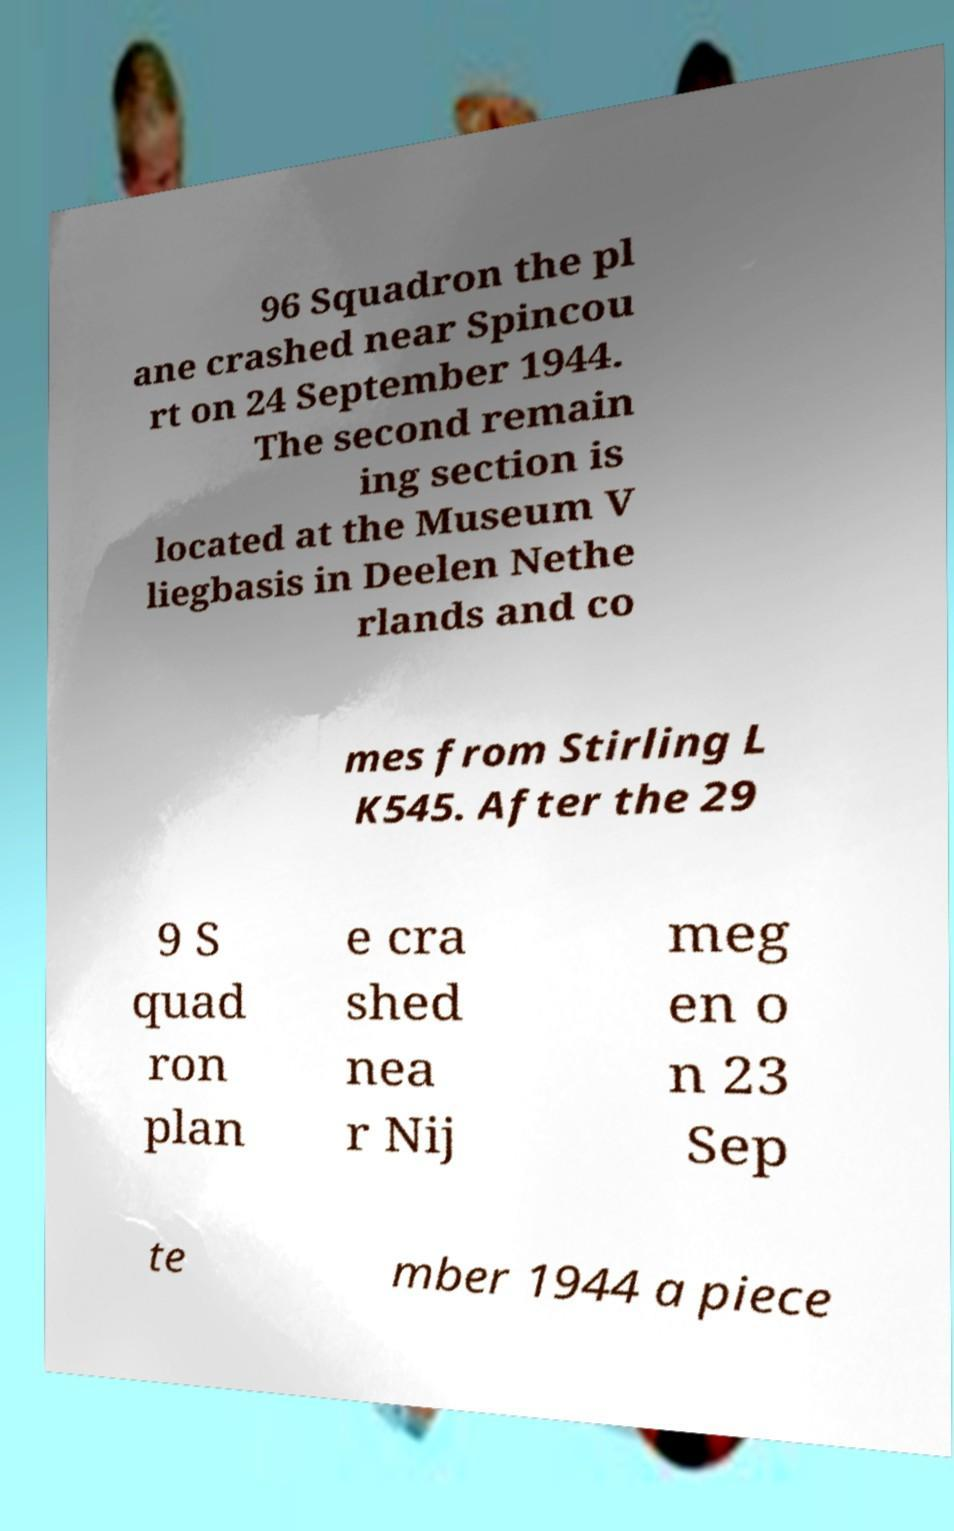Please identify and transcribe the text found in this image. 96 Squadron the pl ane crashed near Spincou rt on 24 September 1944. The second remain ing section is located at the Museum V liegbasis in Deelen Nethe rlands and co mes from Stirling L K545. After the 29 9 S quad ron plan e cra shed nea r Nij meg en o n 23 Sep te mber 1944 a piece 